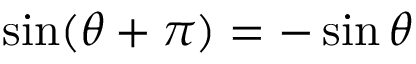Convert formula to latex. <formula><loc_0><loc_0><loc_500><loc_500>\sin ( \theta + \pi ) = - \sin \theta</formula> 